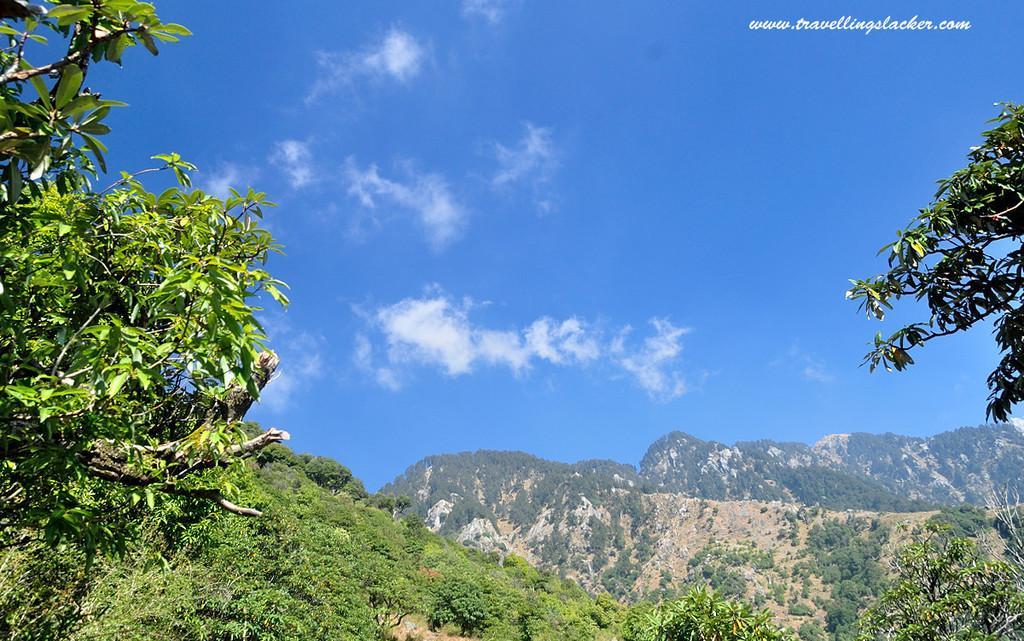Can you describe this image briefly? On the left side we can see trees. On the right side there is a branch. In the back there are mountains with trees. In the background there is sky with clouds. On the right corner there is a watermark. 